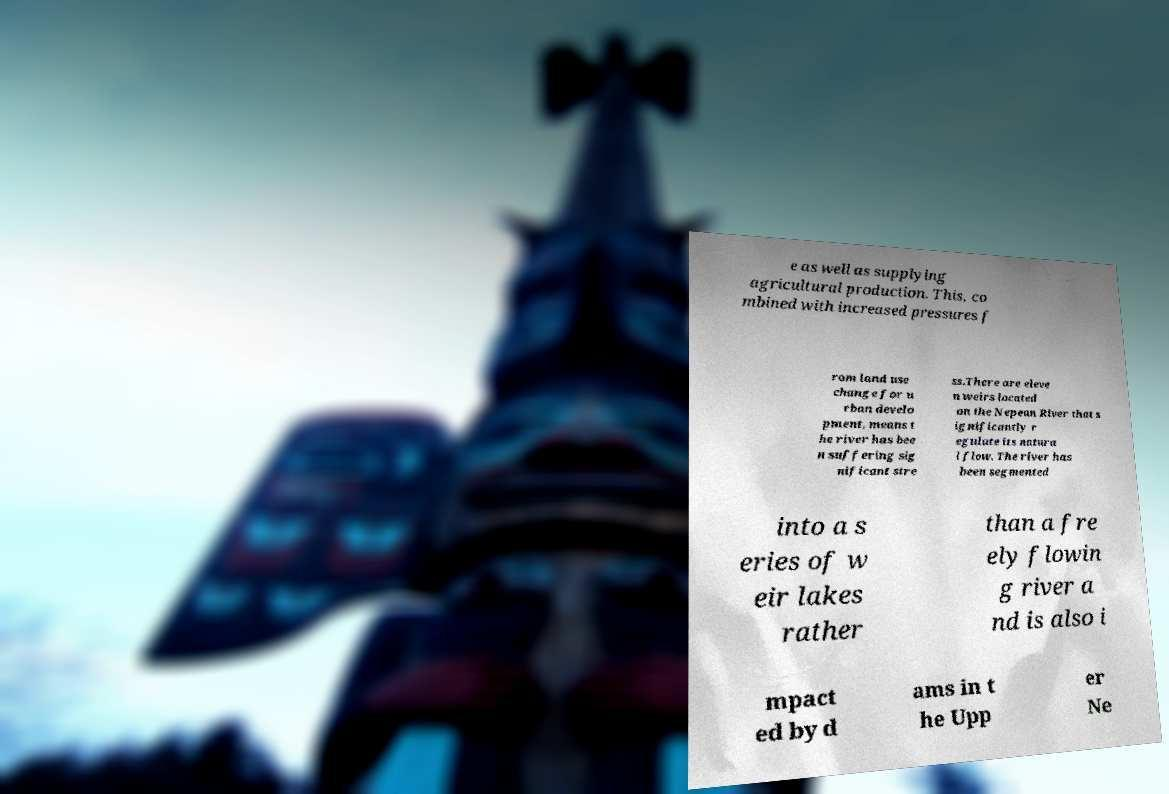There's text embedded in this image that I need extracted. Can you transcribe it verbatim? e as well as supplying agricultural production. This, co mbined with increased pressures f rom land use change for u rban develo pment, means t he river has bee n suffering sig nificant stre ss.There are eleve n weirs located on the Nepean River that s ignificantly r egulate its natura l flow. The river has been segmented into a s eries of w eir lakes rather than a fre ely flowin g river a nd is also i mpact ed by d ams in t he Upp er Ne 